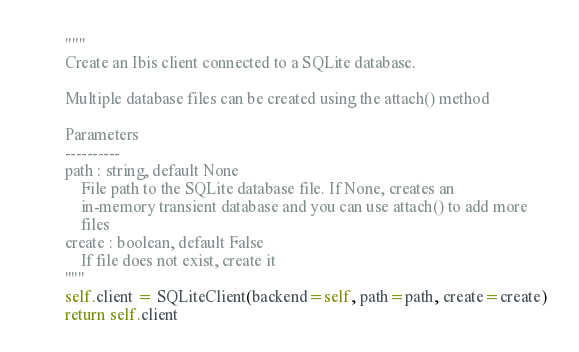<code> <loc_0><loc_0><loc_500><loc_500><_Python_>
        """
        Create an Ibis client connected to a SQLite database.

        Multiple database files can be created using the attach() method

        Parameters
        ----------
        path : string, default None
            File path to the SQLite database file. If None, creates an
            in-memory transient database and you can use attach() to add more
            files
        create : boolean, default False
            If file does not exist, create it
        """
        self.client = SQLiteClient(backend=self, path=path, create=create)
        return self.client
</code> 